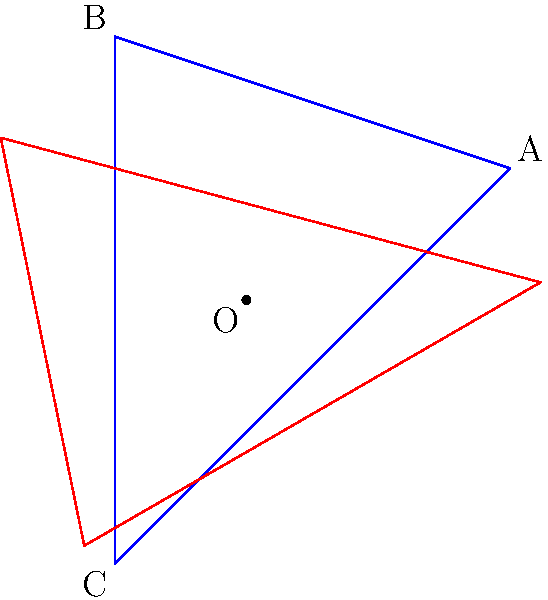A specialty coffee shop's logo is represented by triangle ABC in the diagram. If the logo is rotated 120° counterclockwise around point O, what are the coordinates of point A after the rotation? To find the coordinates of point A after rotation, we can follow these steps:

1. Identify the initial coordinates of point A: $(2,1)$

2. Use the rotation matrix for a counterclockwise rotation of $\theta$ degrees:
   $$\begin{bmatrix} \cos\theta & -\sin\theta \\ \sin\theta & \cos\theta \end{bmatrix}$$

3. For a 120° rotation, $\theta = 120°$:
   $$\cos 120° = -\frac{1}{2}, \sin 120° = \frac{\sqrt{3}}{2}$$

4. Apply the rotation matrix to point A:
   $$\begin{bmatrix} -\frac{1}{2} & -\frac{\sqrt{3}}{2} \\ \frac{\sqrt{3}}{2} & -\frac{1}{2} \end{bmatrix} \begin{bmatrix} 2 \\ 1 \end{bmatrix}$$

5. Multiply the matrices:
   $$\begin{bmatrix} (-\frac{1}{2})(2) + (-\frac{\sqrt{3}}{2})(1) \\ (\frac{\sqrt{3}}{2})(2) + (-\frac{1}{2})(1) \end{bmatrix} = \begin{bmatrix} -1 - \frac{\sqrt{3}}{2} \\ \sqrt{3} - \frac{1}{2} \end{bmatrix}$$

6. Simplify:
   $$\begin{bmatrix} -\frac{2+\sqrt{3}}{2} \\ \frac{2\sqrt{3}-1}{2} \end{bmatrix}$$

Therefore, the coordinates of point A after rotation are $(-\frac{2+\sqrt{3}}{2}, \frac{2\sqrt{3}-1}{2})$.
Answer: $(-\frac{2+\sqrt{3}}{2}, \frac{2\sqrt{3}-1}{2})$ 